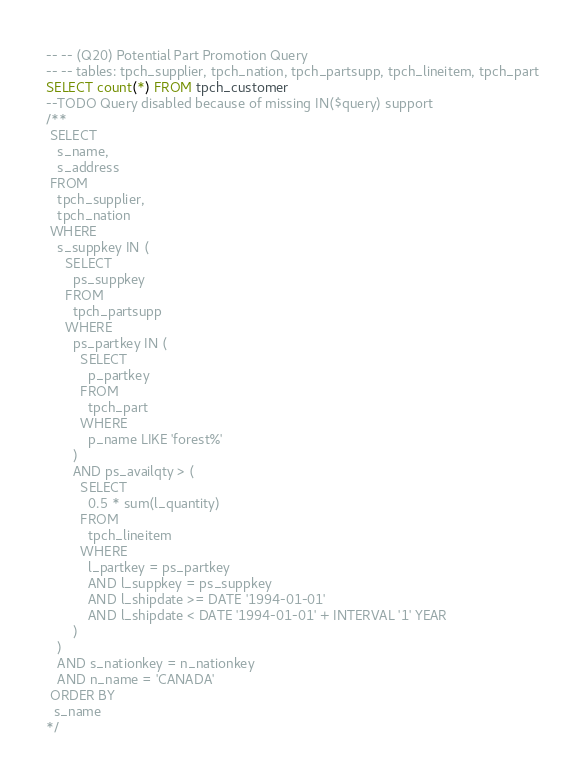<code> <loc_0><loc_0><loc_500><loc_500><_SQL_>-- -- (Q20) Potential Part Promotion Query
-- -- tables: tpch_supplier, tpch_nation, tpch_partsupp, tpch_lineitem, tpch_part
SELECT count(*) FROM tpch_customer
--TODO Query disabled because of missing IN($query) support
/**
 SELECT
   s_name,
   s_address
 FROM
   tpch_supplier,
   tpch_nation
 WHERE
   s_suppkey IN (
     SELECT
       ps_suppkey
     FROM
       tpch_partsupp
     WHERE
       ps_partkey IN (
         SELECT
           p_partkey
         FROM
           tpch_part
         WHERE
           p_name LIKE 'forest%'
       )
       AND ps_availqty > (
         SELECT
           0.5 * sum(l_quantity)
         FROM
           tpch_lineitem
         WHERE
           l_partkey = ps_partkey
           AND l_suppkey = ps_suppkey
           AND l_shipdate >= DATE '1994-01-01'
           AND l_shipdate < DATE '1994-01-01' + INTERVAL '1' YEAR
       )
   )
   AND s_nationkey = n_nationkey
   AND n_name = 'CANADA'
 ORDER BY
  s_name
*/</code> 